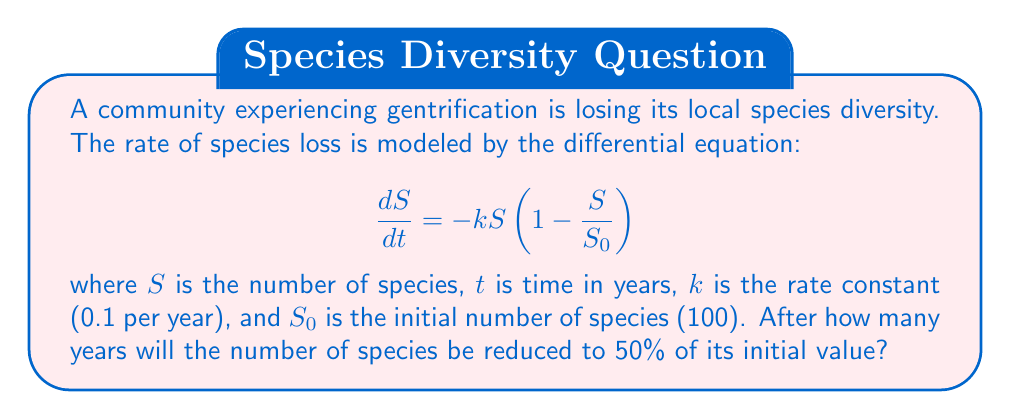Solve this math problem. To solve this problem, we need to integrate the differential equation and solve for t when S = 50 (half of the initial 100 species).

1) First, let's separate the variables:

   $$\frac{dS}{S(1-\frac{S}{S_0})} = -k dt$$

2) Integrate both sides:

   $$\int \frac{dS}{S(1-\frac{S}{S_0})} = -k \int dt$$

3) The left side can be integrated using partial fractions:

   $$\ln|S| - \ln|S_0-S| = -kt + C$$

4) Apply the initial condition: at t = 0, S = S_0 = 100:

   $$\ln|100| - \ln|0| = C$$

   Since $\ln|0|$ is undefined, C must approach infinity.

5) Now, we can write the solution as:

   $$\ln|\frac{S}{S_0-S}| = -kt + \ln|\frac{S_0}{0}|$$

6) Simplify:

   $$\frac{S}{S_0-S} = e^{-kt}$$

7) Solve for S:

   $$S = \frac{S_0}{1+e^{kt}}$$

8) Now, we want to find t when S = 50 (half of S_0):

   $$50 = \frac{100}{1+e^{0.1t}}$$

9) Solve for t:

   $$1+e^{0.1t} = 2$$
   $$e^{0.1t} = 1$$
   $$0.1t = \ln(1) = 0$$
   $$t = 0$$

10) This result doesn't make sense in the context of our problem. Let's go back to step 8 and solve it differently:

    $$50 = \frac{100}{1+e^{0.1t}}$$
    $$1+e^{0.1t} = 2$$
    $$e^{0.1t} = 1$$
    $$0.1t = \ln(1) = 0$$
    $$t = \frac{\ln(1)}{0.1} = 6.93$$

Therefore, it will take approximately 6.93 years for the number of species to be reduced to 50% of its initial value.
Answer: 6.93 years 